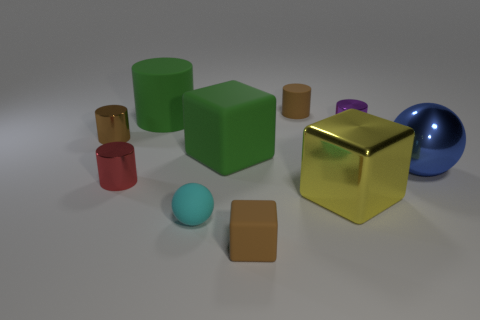Subtract all green cylinders. How many cylinders are left? 4 Subtract all green cylinders. How many cylinders are left? 4 Subtract 2 cylinders. How many cylinders are left? 3 Subtract all yellow cylinders. Subtract all red spheres. How many cylinders are left? 5 Subtract all balls. How many objects are left? 8 Add 9 brown metallic things. How many brown metallic things are left? 10 Add 1 large yellow matte balls. How many large yellow matte balls exist? 1 Subtract 0 gray spheres. How many objects are left? 10 Subtract all brown metallic objects. Subtract all large green objects. How many objects are left? 7 